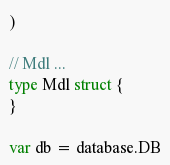<code> <loc_0><loc_0><loc_500><loc_500><_Go_>)

// Mdl ...
type Mdl struct {
}

var db = database.DB
</code> 